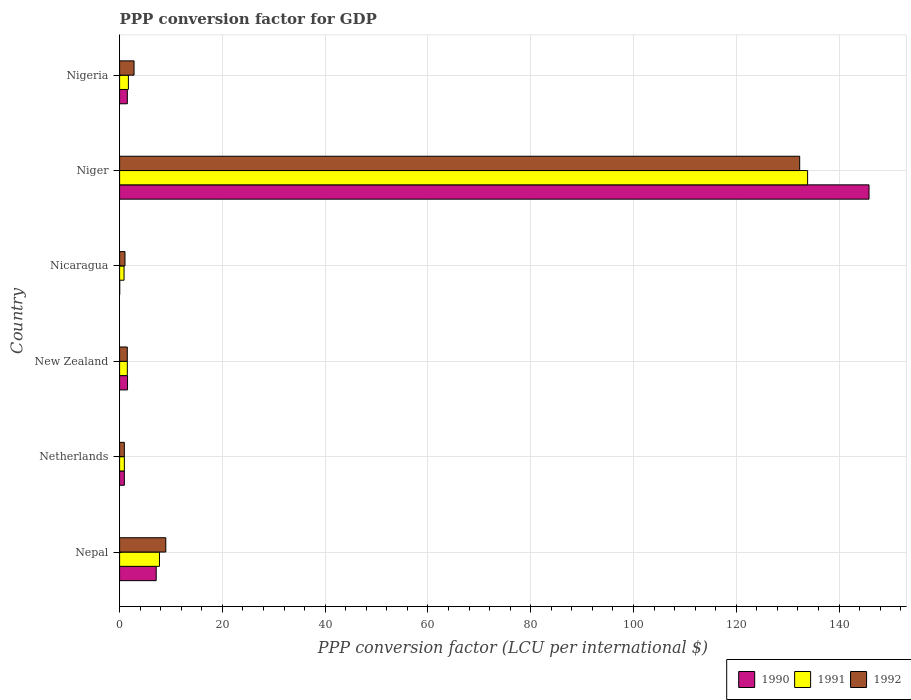How many groups of bars are there?
Your response must be concise. 6. Are the number of bars per tick equal to the number of legend labels?
Provide a short and direct response. Yes. Are the number of bars on each tick of the Y-axis equal?
Keep it short and to the point. Yes. How many bars are there on the 2nd tick from the top?
Ensure brevity in your answer.  3. How many bars are there on the 1st tick from the bottom?
Make the answer very short. 3. What is the PPP conversion factor for GDP in 1992 in Niger?
Provide a succinct answer. 132.34. Across all countries, what is the maximum PPP conversion factor for GDP in 1990?
Make the answer very short. 145.83. Across all countries, what is the minimum PPP conversion factor for GDP in 1992?
Your answer should be compact. 0.92. In which country was the PPP conversion factor for GDP in 1992 maximum?
Make the answer very short. Niger. In which country was the PPP conversion factor for GDP in 1990 minimum?
Provide a succinct answer. Nicaragua. What is the total PPP conversion factor for GDP in 1990 in the graph?
Provide a succinct answer. 156.95. What is the difference between the PPP conversion factor for GDP in 1992 in Nepal and that in New Zealand?
Ensure brevity in your answer.  7.49. What is the difference between the PPP conversion factor for GDP in 1991 in New Zealand and the PPP conversion factor for GDP in 1990 in Nicaragua?
Offer a very short reply. 1.48. What is the average PPP conversion factor for GDP in 1990 per country?
Your answer should be very brief. 26.16. What is the difference between the PPP conversion factor for GDP in 1992 and PPP conversion factor for GDP in 1990 in Netherlands?
Offer a very short reply. 5.700000000008476e-5. What is the ratio of the PPP conversion factor for GDP in 1991 in New Zealand to that in Nigeria?
Your answer should be compact. 0.88. What is the difference between the highest and the second highest PPP conversion factor for GDP in 1991?
Your answer should be compact. 126.12. What is the difference between the highest and the lowest PPP conversion factor for GDP in 1992?
Make the answer very short. 131.42. In how many countries, is the PPP conversion factor for GDP in 1991 greater than the average PPP conversion factor for GDP in 1991 taken over all countries?
Your answer should be very brief. 1. Is the sum of the PPP conversion factor for GDP in 1992 in New Zealand and Nigeria greater than the maximum PPP conversion factor for GDP in 1991 across all countries?
Offer a very short reply. No. What does the 2nd bar from the bottom in Nicaragua represents?
Your response must be concise. 1991. How many bars are there?
Give a very brief answer. 18. What is the difference between two consecutive major ticks on the X-axis?
Your answer should be very brief. 20. Does the graph contain any zero values?
Provide a succinct answer. No. Does the graph contain grids?
Offer a terse response. Yes. How many legend labels are there?
Provide a succinct answer. 3. How are the legend labels stacked?
Give a very brief answer. Horizontal. What is the title of the graph?
Keep it short and to the point. PPP conversion factor for GDP. Does "1960" appear as one of the legend labels in the graph?
Make the answer very short. No. What is the label or title of the X-axis?
Ensure brevity in your answer.  PPP conversion factor (LCU per international $). What is the label or title of the Y-axis?
Keep it short and to the point. Country. What is the PPP conversion factor (LCU per international $) in 1990 in Nepal?
Your response must be concise. 7.12. What is the PPP conversion factor (LCU per international $) in 1991 in Nepal?
Your answer should be very brief. 7.76. What is the PPP conversion factor (LCU per international $) of 1992 in Nepal?
Your response must be concise. 8.99. What is the PPP conversion factor (LCU per international $) of 1990 in Netherlands?
Keep it short and to the point. 0.92. What is the PPP conversion factor (LCU per international $) of 1991 in Netherlands?
Provide a short and direct response. 0.92. What is the PPP conversion factor (LCU per international $) in 1992 in Netherlands?
Offer a terse response. 0.92. What is the PPP conversion factor (LCU per international $) of 1990 in New Zealand?
Your answer should be compact. 1.54. What is the PPP conversion factor (LCU per international $) of 1991 in New Zealand?
Give a very brief answer. 1.5. What is the PPP conversion factor (LCU per international $) of 1992 in New Zealand?
Your response must be concise. 1.49. What is the PPP conversion factor (LCU per international $) of 1990 in Nicaragua?
Your answer should be very brief. 0.02. What is the PPP conversion factor (LCU per international $) in 1991 in Nicaragua?
Your answer should be compact. 0.87. What is the PPP conversion factor (LCU per international $) in 1992 in Nicaragua?
Provide a succinct answer. 1.05. What is the PPP conversion factor (LCU per international $) in 1990 in Niger?
Offer a terse response. 145.83. What is the PPP conversion factor (LCU per international $) in 1991 in Niger?
Ensure brevity in your answer.  133.88. What is the PPP conversion factor (LCU per international $) of 1992 in Niger?
Your answer should be compact. 132.34. What is the PPP conversion factor (LCU per international $) of 1990 in Nigeria?
Your answer should be very brief. 1.5. What is the PPP conversion factor (LCU per international $) in 1991 in Nigeria?
Provide a succinct answer. 1.71. What is the PPP conversion factor (LCU per international $) of 1992 in Nigeria?
Your response must be concise. 2.81. Across all countries, what is the maximum PPP conversion factor (LCU per international $) in 1990?
Provide a short and direct response. 145.83. Across all countries, what is the maximum PPP conversion factor (LCU per international $) in 1991?
Provide a succinct answer. 133.88. Across all countries, what is the maximum PPP conversion factor (LCU per international $) in 1992?
Offer a terse response. 132.34. Across all countries, what is the minimum PPP conversion factor (LCU per international $) of 1990?
Offer a very short reply. 0.02. Across all countries, what is the minimum PPP conversion factor (LCU per international $) of 1991?
Offer a very short reply. 0.87. Across all countries, what is the minimum PPP conversion factor (LCU per international $) in 1992?
Your response must be concise. 0.92. What is the total PPP conversion factor (LCU per international $) in 1990 in the graph?
Make the answer very short. 156.95. What is the total PPP conversion factor (LCU per international $) in 1991 in the graph?
Your answer should be very brief. 146.64. What is the total PPP conversion factor (LCU per international $) in 1992 in the graph?
Provide a short and direct response. 147.6. What is the difference between the PPP conversion factor (LCU per international $) in 1990 in Nepal and that in Netherlands?
Ensure brevity in your answer.  6.2. What is the difference between the PPP conversion factor (LCU per international $) of 1991 in Nepal and that in Netherlands?
Make the answer very short. 6.84. What is the difference between the PPP conversion factor (LCU per international $) of 1992 in Nepal and that in Netherlands?
Your answer should be compact. 8.07. What is the difference between the PPP conversion factor (LCU per international $) of 1990 in Nepal and that in New Zealand?
Your answer should be very brief. 5.58. What is the difference between the PPP conversion factor (LCU per international $) of 1991 in Nepal and that in New Zealand?
Your response must be concise. 6.26. What is the difference between the PPP conversion factor (LCU per international $) in 1992 in Nepal and that in New Zealand?
Provide a succinct answer. 7.49. What is the difference between the PPP conversion factor (LCU per international $) in 1990 in Nepal and that in Nicaragua?
Provide a short and direct response. 7.1. What is the difference between the PPP conversion factor (LCU per international $) in 1991 in Nepal and that in Nicaragua?
Ensure brevity in your answer.  6.89. What is the difference between the PPP conversion factor (LCU per international $) of 1992 in Nepal and that in Nicaragua?
Ensure brevity in your answer.  7.94. What is the difference between the PPP conversion factor (LCU per international $) in 1990 in Nepal and that in Niger?
Ensure brevity in your answer.  -138.71. What is the difference between the PPP conversion factor (LCU per international $) of 1991 in Nepal and that in Niger?
Ensure brevity in your answer.  -126.12. What is the difference between the PPP conversion factor (LCU per international $) in 1992 in Nepal and that in Niger?
Your answer should be very brief. -123.35. What is the difference between the PPP conversion factor (LCU per international $) of 1990 in Nepal and that in Nigeria?
Offer a terse response. 5.62. What is the difference between the PPP conversion factor (LCU per international $) in 1991 in Nepal and that in Nigeria?
Offer a very short reply. 6.05. What is the difference between the PPP conversion factor (LCU per international $) of 1992 in Nepal and that in Nigeria?
Your answer should be compact. 6.18. What is the difference between the PPP conversion factor (LCU per international $) in 1990 in Netherlands and that in New Zealand?
Provide a short and direct response. -0.62. What is the difference between the PPP conversion factor (LCU per international $) in 1991 in Netherlands and that in New Zealand?
Give a very brief answer. -0.58. What is the difference between the PPP conversion factor (LCU per international $) in 1992 in Netherlands and that in New Zealand?
Your answer should be compact. -0.57. What is the difference between the PPP conversion factor (LCU per international $) in 1990 in Netherlands and that in Nicaragua?
Provide a short and direct response. 0.9. What is the difference between the PPP conversion factor (LCU per international $) in 1991 in Netherlands and that in Nicaragua?
Keep it short and to the point. 0.06. What is the difference between the PPP conversion factor (LCU per international $) in 1992 in Netherlands and that in Nicaragua?
Your answer should be compact. -0.12. What is the difference between the PPP conversion factor (LCU per international $) in 1990 in Netherlands and that in Niger?
Keep it short and to the point. -144.91. What is the difference between the PPP conversion factor (LCU per international $) in 1991 in Netherlands and that in Niger?
Make the answer very short. -132.96. What is the difference between the PPP conversion factor (LCU per international $) in 1992 in Netherlands and that in Niger?
Your response must be concise. -131.42. What is the difference between the PPP conversion factor (LCU per international $) of 1990 in Netherlands and that in Nigeria?
Provide a succinct answer. -0.58. What is the difference between the PPP conversion factor (LCU per international $) of 1991 in Netherlands and that in Nigeria?
Offer a terse response. -0.79. What is the difference between the PPP conversion factor (LCU per international $) of 1992 in Netherlands and that in Nigeria?
Ensure brevity in your answer.  -1.89. What is the difference between the PPP conversion factor (LCU per international $) in 1990 in New Zealand and that in Nicaragua?
Your response must be concise. 1.52. What is the difference between the PPP conversion factor (LCU per international $) in 1991 in New Zealand and that in Nicaragua?
Give a very brief answer. 0.64. What is the difference between the PPP conversion factor (LCU per international $) in 1992 in New Zealand and that in Nicaragua?
Ensure brevity in your answer.  0.45. What is the difference between the PPP conversion factor (LCU per international $) in 1990 in New Zealand and that in Niger?
Offer a very short reply. -144.29. What is the difference between the PPP conversion factor (LCU per international $) in 1991 in New Zealand and that in Niger?
Keep it short and to the point. -132.38. What is the difference between the PPP conversion factor (LCU per international $) in 1992 in New Zealand and that in Niger?
Your answer should be compact. -130.85. What is the difference between the PPP conversion factor (LCU per international $) in 1990 in New Zealand and that in Nigeria?
Provide a short and direct response. 0.04. What is the difference between the PPP conversion factor (LCU per international $) in 1991 in New Zealand and that in Nigeria?
Your answer should be compact. -0.21. What is the difference between the PPP conversion factor (LCU per international $) in 1992 in New Zealand and that in Nigeria?
Offer a very short reply. -1.32. What is the difference between the PPP conversion factor (LCU per international $) in 1990 in Nicaragua and that in Niger?
Offer a terse response. -145.81. What is the difference between the PPP conversion factor (LCU per international $) of 1991 in Nicaragua and that in Niger?
Keep it short and to the point. -133.02. What is the difference between the PPP conversion factor (LCU per international $) in 1992 in Nicaragua and that in Niger?
Provide a short and direct response. -131.29. What is the difference between the PPP conversion factor (LCU per international $) in 1990 in Nicaragua and that in Nigeria?
Offer a terse response. -1.48. What is the difference between the PPP conversion factor (LCU per international $) of 1991 in Nicaragua and that in Nigeria?
Offer a very short reply. -0.85. What is the difference between the PPP conversion factor (LCU per international $) in 1992 in Nicaragua and that in Nigeria?
Offer a very short reply. -1.77. What is the difference between the PPP conversion factor (LCU per international $) in 1990 in Niger and that in Nigeria?
Your response must be concise. 144.33. What is the difference between the PPP conversion factor (LCU per international $) of 1991 in Niger and that in Nigeria?
Keep it short and to the point. 132.17. What is the difference between the PPP conversion factor (LCU per international $) in 1992 in Niger and that in Nigeria?
Offer a very short reply. 129.53. What is the difference between the PPP conversion factor (LCU per international $) in 1990 in Nepal and the PPP conversion factor (LCU per international $) in 1991 in Netherlands?
Your answer should be very brief. 6.2. What is the difference between the PPP conversion factor (LCU per international $) in 1990 in Nepal and the PPP conversion factor (LCU per international $) in 1992 in Netherlands?
Keep it short and to the point. 6.2. What is the difference between the PPP conversion factor (LCU per international $) in 1991 in Nepal and the PPP conversion factor (LCU per international $) in 1992 in Netherlands?
Give a very brief answer. 6.84. What is the difference between the PPP conversion factor (LCU per international $) in 1990 in Nepal and the PPP conversion factor (LCU per international $) in 1991 in New Zealand?
Offer a very short reply. 5.62. What is the difference between the PPP conversion factor (LCU per international $) of 1990 in Nepal and the PPP conversion factor (LCU per international $) of 1992 in New Zealand?
Your answer should be compact. 5.63. What is the difference between the PPP conversion factor (LCU per international $) in 1991 in Nepal and the PPP conversion factor (LCU per international $) in 1992 in New Zealand?
Ensure brevity in your answer.  6.26. What is the difference between the PPP conversion factor (LCU per international $) of 1990 in Nepal and the PPP conversion factor (LCU per international $) of 1991 in Nicaragua?
Provide a succinct answer. 6.26. What is the difference between the PPP conversion factor (LCU per international $) in 1990 in Nepal and the PPP conversion factor (LCU per international $) in 1992 in Nicaragua?
Provide a succinct answer. 6.08. What is the difference between the PPP conversion factor (LCU per international $) of 1991 in Nepal and the PPP conversion factor (LCU per international $) of 1992 in Nicaragua?
Make the answer very short. 6.71. What is the difference between the PPP conversion factor (LCU per international $) in 1990 in Nepal and the PPP conversion factor (LCU per international $) in 1991 in Niger?
Offer a terse response. -126.76. What is the difference between the PPP conversion factor (LCU per international $) in 1990 in Nepal and the PPP conversion factor (LCU per international $) in 1992 in Niger?
Provide a short and direct response. -125.22. What is the difference between the PPP conversion factor (LCU per international $) in 1991 in Nepal and the PPP conversion factor (LCU per international $) in 1992 in Niger?
Provide a short and direct response. -124.58. What is the difference between the PPP conversion factor (LCU per international $) of 1990 in Nepal and the PPP conversion factor (LCU per international $) of 1991 in Nigeria?
Offer a terse response. 5.41. What is the difference between the PPP conversion factor (LCU per international $) of 1990 in Nepal and the PPP conversion factor (LCU per international $) of 1992 in Nigeria?
Give a very brief answer. 4.31. What is the difference between the PPP conversion factor (LCU per international $) of 1991 in Nepal and the PPP conversion factor (LCU per international $) of 1992 in Nigeria?
Your answer should be very brief. 4.95. What is the difference between the PPP conversion factor (LCU per international $) of 1990 in Netherlands and the PPP conversion factor (LCU per international $) of 1991 in New Zealand?
Give a very brief answer. -0.58. What is the difference between the PPP conversion factor (LCU per international $) in 1990 in Netherlands and the PPP conversion factor (LCU per international $) in 1992 in New Zealand?
Your response must be concise. -0.57. What is the difference between the PPP conversion factor (LCU per international $) of 1991 in Netherlands and the PPP conversion factor (LCU per international $) of 1992 in New Zealand?
Your answer should be compact. -0.57. What is the difference between the PPP conversion factor (LCU per international $) in 1990 in Netherlands and the PPP conversion factor (LCU per international $) in 1991 in Nicaragua?
Provide a short and direct response. 0.06. What is the difference between the PPP conversion factor (LCU per international $) in 1990 in Netherlands and the PPP conversion factor (LCU per international $) in 1992 in Nicaragua?
Offer a very short reply. -0.12. What is the difference between the PPP conversion factor (LCU per international $) of 1991 in Netherlands and the PPP conversion factor (LCU per international $) of 1992 in Nicaragua?
Your response must be concise. -0.13. What is the difference between the PPP conversion factor (LCU per international $) in 1990 in Netherlands and the PPP conversion factor (LCU per international $) in 1991 in Niger?
Your answer should be compact. -132.96. What is the difference between the PPP conversion factor (LCU per international $) of 1990 in Netherlands and the PPP conversion factor (LCU per international $) of 1992 in Niger?
Offer a terse response. -131.42. What is the difference between the PPP conversion factor (LCU per international $) of 1991 in Netherlands and the PPP conversion factor (LCU per international $) of 1992 in Niger?
Keep it short and to the point. -131.42. What is the difference between the PPP conversion factor (LCU per international $) of 1990 in Netherlands and the PPP conversion factor (LCU per international $) of 1991 in Nigeria?
Your answer should be compact. -0.79. What is the difference between the PPP conversion factor (LCU per international $) of 1990 in Netherlands and the PPP conversion factor (LCU per international $) of 1992 in Nigeria?
Give a very brief answer. -1.89. What is the difference between the PPP conversion factor (LCU per international $) of 1991 in Netherlands and the PPP conversion factor (LCU per international $) of 1992 in Nigeria?
Provide a succinct answer. -1.89. What is the difference between the PPP conversion factor (LCU per international $) in 1990 in New Zealand and the PPP conversion factor (LCU per international $) in 1991 in Nicaragua?
Offer a very short reply. 0.68. What is the difference between the PPP conversion factor (LCU per international $) of 1990 in New Zealand and the PPP conversion factor (LCU per international $) of 1992 in Nicaragua?
Ensure brevity in your answer.  0.5. What is the difference between the PPP conversion factor (LCU per international $) in 1991 in New Zealand and the PPP conversion factor (LCU per international $) in 1992 in Nicaragua?
Your answer should be compact. 0.46. What is the difference between the PPP conversion factor (LCU per international $) of 1990 in New Zealand and the PPP conversion factor (LCU per international $) of 1991 in Niger?
Make the answer very short. -132.34. What is the difference between the PPP conversion factor (LCU per international $) of 1990 in New Zealand and the PPP conversion factor (LCU per international $) of 1992 in Niger?
Provide a short and direct response. -130.8. What is the difference between the PPP conversion factor (LCU per international $) of 1991 in New Zealand and the PPP conversion factor (LCU per international $) of 1992 in Niger?
Ensure brevity in your answer.  -130.84. What is the difference between the PPP conversion factor (LCU per international $) in 1990 in New Zealand and the PPP conversion factor (LCU per international $) in 1991 in Nigeria?
Offer a terse response. -0.17. What is the difference between the PPP conversion factor (LCU per international $) of 1990 in New Zealand and the PPP conversion factor (LCU per international $) of 1992 in Nigeria?
Your answer should be compact. -1.27. What is the difference between the PPP conversion factor (LCU per international $) in 1991 in New Zealand and the PPP conversion factor (LCU per international $) in 1992 in Nigeria?
Your response must be concise. -1.31. What is the difference between the PPP conversion factor (LCU per international $) in 1990 in Nicaragua and the PPP conversion factor (LCU per international $) in 1991 in Niger?
Make the answer very short. -133.86. What is the difference between the PPP conversion factor (LCU per international $) of 1990 in Nicaragua and the PPP conversion factor (LCU per international $) of 1992 in Niger?
Give a very brief answer. -132.32. What is the difference between the PPP conversion factor (LCU per international $) of 1991 in Nicaragua and the PPP conversion factor (LCU per international $) of 1992 in Niger?
Your answer should be very brief. -131.47. What is the difference between the PPP conversion factor (LCU per international $) in 1990 in Nicaragua and the PPP conversion factor (LCU per international $) in 1991 in Nigeria?
Provide a succinct answer. -1.69. What is the difference between the PPP conversion factor (LCU per international $) of 1990 in Nicaragua and the PPP conversion factor (LCU per international $) of 1992 in Nigeria?
Offer a very short reply. -2.79. What is the difference between the PPP conversion factor (LCU per international $) of 1991 in Nicaragua and the PPP conversion factor (LCU per international $) of 1992 in Nigeria?
Your answer should be compact. -1.95. What is the difference between the PPP conversion factor (LCU per international $) in 1990 in Niger and the PPP conversion factor (LCU per international $) in 1991 in Nigeria?
Offer a terse response. 144.12. What is the difference between the PPP conversion factor (LCU per international $) in 1990 in Niger and the PPP conversion factor (LCU per international $) in 1992 in Nigeria?
Provide a short and direct response. 143.02. What is the difference between the PPP conversion factor (LCU per international $) in 1991 in Niger and the PPP conversion factor (LCU per international $) in 1992 in Nigeria?
Your response must be concise. 131.07. What is the average PPP conversion factor (LCU per international $) in 1990 per country?
Your response must be concise. 26.16. What is the average PPP conversion factor (LCU per international $) of 1991 per country?
Your response must be concise. 24.44. What is the average PPP conversion factor (LCU per international $) of 1992 per country?
Make the answer very short. 24.6. What is the difference between the PPP conversion factor (LCU per international $) in 1990 and PPP conversion factor (LCU per international $) in 1991 in Nepal?
Your answer should be very brief. -0.64. What is the difference between the PPP conversion factor (LCU per international $) of 1990 and PPP conversion factor (LCU per international $) of 1992 in Nepal?
Offer a very short reply. -1.87. What is the difference between the PPP conversion factor (LCU per international $) of 1991 and PPP conversion factor (LCU per international $) of 1992 in Nepal?
Your answer should be very brief. -1.23. What is the difference between the PPP conversion factor (LCU per international $) of 1990 and PPP conversion factor (LCU per international $) of 1991 in Netherlands?
Your answer should be compact. 0. What is the difference between the PPP conversion factor (LCU per international $) of 1990 and PPP conversion factor (LCU per international $) of 1992 in Netherlands?
Make the answer very short. -0. What is the difference between the PPP conversion factor (LCU per international $) of 1991 and PPP conversion factor (LCU per international $) of 1992 in Netherlands?
Offer a terse response. -0. What is the difference between the PPP conversion factor (LCU per international $) of 1990 and PPP conversion factor (LCU per international $) of 1991 in New Zealand?
Offer a very short reply. 0.04. What is the difference between the PPP conversion factor (LCU per international $) of 1990 and PPP conversion factor (LCU per international $) of 1992 in New Zealand?
Provide a short and direct response. 0.05. What is the difference between the PPP conversion factor (LCU per international $) in 1991 and PPP conversion factor (LCU per international $) in 1992 in New Zealand?
Provide a succinct answer. 0.01. What is the difference between the PPP conversion factor (LCU per international $) in 1990 and PPP conversion factor (LCU per international $) in 1991 in Nicaragua?
Provide a short and direct response. -0.85. What is the difference between the PPP conversion factor (LCU per international $) of 1990 and PPP conversion factor (LCU per international $) of 1992 in Nicaragua?
Make the answer very short. -1.03. What is the difference between the PPP conversion factor (LCU per international $) of 1991 and PPP conversion factor (LCU per international $) of 1992 in Nicaragua?
Your response must be concise. -0.18. What is the difference between the PPP conversion factor (LCU per international $) in 1990 and PPP conversion factor (LCU per international $) in 1991 in Niger?
Ensure brevity in your answer.  11.95. What is the difference between the PPP conversion factor (LCU per international $) of 1990 and PPP conversion factor (LCU per international $) of 1992 in Niger?
Keep it short and to the point. 13.49. What is the difference between the PPP conversion factor (LCU per international $) in 1991 and PPP conversion factor (LCU per international $) in 1992 in Niger?
Offer a very short reply. 1.54. What is the difference between the PPP conversion factor (LCU per international $) of 1990 and PPP conversion factor (LCU per international $) of 1991 in Nigeria?
Keep it short and to the point. -0.21. What is the difference between the PPP conversion factor (LCU per international $) in 1990 and PPP conversion factor (LCU per international $) in 1992 in Nigeria?
Give a very brief answer. -1.31. What is the difference between the PPP conversion factor (LCU per international $) of 1991 and PPP conversion factor (LCU per international $) of 1992 in Nigeria?
Provide a succinct answer. -1.1. What is the ratio of the PPP conversion factor (LCU per international $) in 1990 in Nepal to that in Netherlands?
Make the answer very short. 7.72. What is the ratio of the PPP conversion factor (LCU per international $) of 1991 in Nepal to that in Netherlands?
Ensure brevity in your answer.  8.42. What is the ratio of the PPP conversion factor (LCU per international $) in 1992 in Nepal to that in Netherlands?
Provide a short and direct response. 9.74. What is the ratio of the PPP conversion factor (LCU per international $) in 1990 in Nepal to that in New Zealand?
Your answer should be very brief. 4.62. What is the ratio of the PPP conversion factor (LCU per international $) of 1991 in Nepal to that in New Zealand?
Offer a very short reply. 5.16. What is the ratio of the PPP conversion factor (LCU per international $) in 1992 in Nepal to that in New Zealand?
Your answer should be compact. 6.02. What is the ratio of the PPP conversion factor (LCU per international $) of 1990 in Nepal to that in Nicaragua?
Offer a terse response. 368.31. What is the ratio of the PPP conversion factor (LCU per international $) in 1991 in Nepal to that in Nicaragua?
Offer a terse response. 8.96. What is the ratio of the PPP conversion factor (LCU per international $) in 1992 in Nepal to that in Nicaragua?
Give a very brief answer. 8.59. What is the ratio of the PPP conversion factor (LCU per international $) of 1990 in Nepal to that in Niger?
Give a very brief answer. 0.05. What is the ratio of the PPP conversion factor (LCU per international $) in 1991 in Nepal to that in Niger?
Offer a terse response. 0.06. What is the ratio of the PPP conversion factor (LCU per international $) in 1992 in Nepal to that in Niger?
Your response must be concise. 0.07. What is the ratio of the PPP conversion factor (LCU per international $) in 1990 in Nepal to that in Nigeria?
Your response must be concise. 4.74. What is the ratio of the PPP conversion factor (LCU per international $) in 1991 in Nepal to that in Nigeria?
Your answer should be very brief. 4.53. What is the ratio of the PPP conversion factor (LCU per international $) of 1992 in Nepal to that in Nigeria?
Ensure brevity in your answer.  3.2. What is the ratio of the PPP conversion factor (LCU per international $) of 1990 in Netherlands to that in New Zealand?
Offer a terse response. 0.6. What is the ratio of the PPP conversion factor (LCU per international $) of 1991 in Netherlands to that in New Zealand?
Provide a short and direct response. 0.61. What is the ratio of the PPP conversion factor (LCU per international $) in 1992 in Netherlands to that in New Zealand?
Provide a succinct answer. 0.62. What is the ratio of the PPP conversion factor (LCU per international $) in 1990 in Netherlands to that in Nicaragua?
Your answer should be compact. 47.73. What is the ratio of the PPP conversion factor (LCU per international $) in 1991 in Netherlands to that in Nicaragua?
Your answer should be compact. 1.06. What is the ratio of the PPP conversion factor (LCU per international $) of 1992 in Netherlands to that in Nicaragua?
Provide a short and direct response. 0.88. What is the ratio of the PPP conversion factor (LCU per international $) in 1990 in Netherlands to that in Niger?
Provide a short and direct response. 0.01. What is the ratio of the PPP conversion factor (LCU per international $) of 1991 in Netherlands to that in Niger?
Your answer should be very brief. 0.01. What is the ratio of the PPP conversion factor (LCU per international $) in 1992 in Netherlands to that in Niger?
Your answer should be very brief. 0.01. What is the ratio of the PPP conversion factor (LCU per international $) in 1990 in Netherlands to that in Nigeria?
Offer a very short reply. 0.61. What is the ratio of the PPP conversion factor (LCU per international $) of 1991 in Netherlands to that in Nigeria?
Make the answer very short. 0.54. What is the ratio of the PPP conversion factor (LCU per international $) in 1992 in Netherlands to that in Nigeria?
Provide a succinct answer. 0.33. What is the ratio of the PPP conversion factor (LCU per international $) in 1990 in New Zealand to that in Nicaragua?
Your answer should be compact. 79.72. What is the ratio of the PPP conversion factor (LCU per international $) of 1991 in New Zealand to that in Nicaragua?
Your answer should be very brief. 1.74. What is the ratio of the PPP conversion factor (LCU per international $) of 1992 in New Zealand to that in Nicaragua?
Your answer should be compact. 1.43. What is the ratio of the PPP conversion factor (LCU per international $) of 1990 in New Zealand to that in Niger?
Your response must be concise. 0.01. What is the ratio of the PPP conversion factor (LCU per international $) of 1991 in New Zealand to that in Niger?
Your answer should be compact. 0.01. What is the ratio of the PPP conversion factor (LCU per international $) in 1992 in New Zealand to that in Niger?
Your answer should be compact. 0.01. What is the ratio of the PPP conversion factor (LCU per international $) of 1990 in New Zealand to that in Nigeria?
Keep it short and to the point. 1.03. What is the ratio of the PPP conversion factor (LCU per international $) in 1991 in New Zealand to that in Nigeria?
Provide a succinct answer. 0.88. What is the ratio of the PPP conversion factor (LCU per international $) in 1992 in New Zealand to that in Nigeria?
Your answer should be compact. 0.53. What is the ratio of the PPP conversion factor (LCU per international $) in 1990 in Nicaragua to that in Niger?
Offer a very short reply. 0. What is the ratio of the PPP conversion factor (LCU per international $) in 1991 in Nicaragua to that in Niger?
Offer a terse response. 0.01. What is the ratio of the PPP conversion factor (LCU per international $) of 1992 in Nicaragua to that in Niger?
Make the answer very short. 0.01. What is the ratio of the PPP conversion factor (LCU per international $) in 1990 in Nicaragua to that in Nigeria?
Make the answer very short. 0.01. What is the ratio of the PPP conversion factor (LCU per international $) of 1991 in Nicaragua to that in Nigeria?
Your answer should be compact. 0.51. What is the ratio of the PPP conversion factor (LCU per international $) of 1992 in Nicaragua to that in Nigeria?
Your answer should be compact. 0.37. What is the ratio of the PPP conversion factor (LCU per international $) of 1990 in Niger to that in Nigeria?
Your response must be concise. 97.01. What is the ratio of the PPP conversion factor (LCU per international $) in 1991 in Niger to that in Nigeria?
Your response must be concise. 78.25. What is the ratio of the PPP conversion factor (LCU per international $) in 1992 in Niger to that in Nigeria?
Your response must be concise. 47.07. What is the difference between the highest and the second highest PPP conversion factor (LCU per international $) of 1990?
Offer a terse response. 138.71. What is the difference between the highest and the second highest PPP conversion factor (LCU per international $) in 1991?
Give a very brief answer. 126.12. What is the difference between the highest and the second highest PPP conversion factor (LCU per international $) in 1992?
Your answer should be very brief. 123.35. What is the difference between the highest and the lowest PPP conversion factor (LCU per international $) in 1990?
Your response must be concise. 145.81. What is the difference between the highest and the lowest PPP conversion factor (LCU per international $) of 1991?
Offer a very short reply. 133.02. What is the difference between the highest and the lowest PPP conversion factor (LCU per international $) in 1992?
Ensure brevity in your answer.  131.42. 